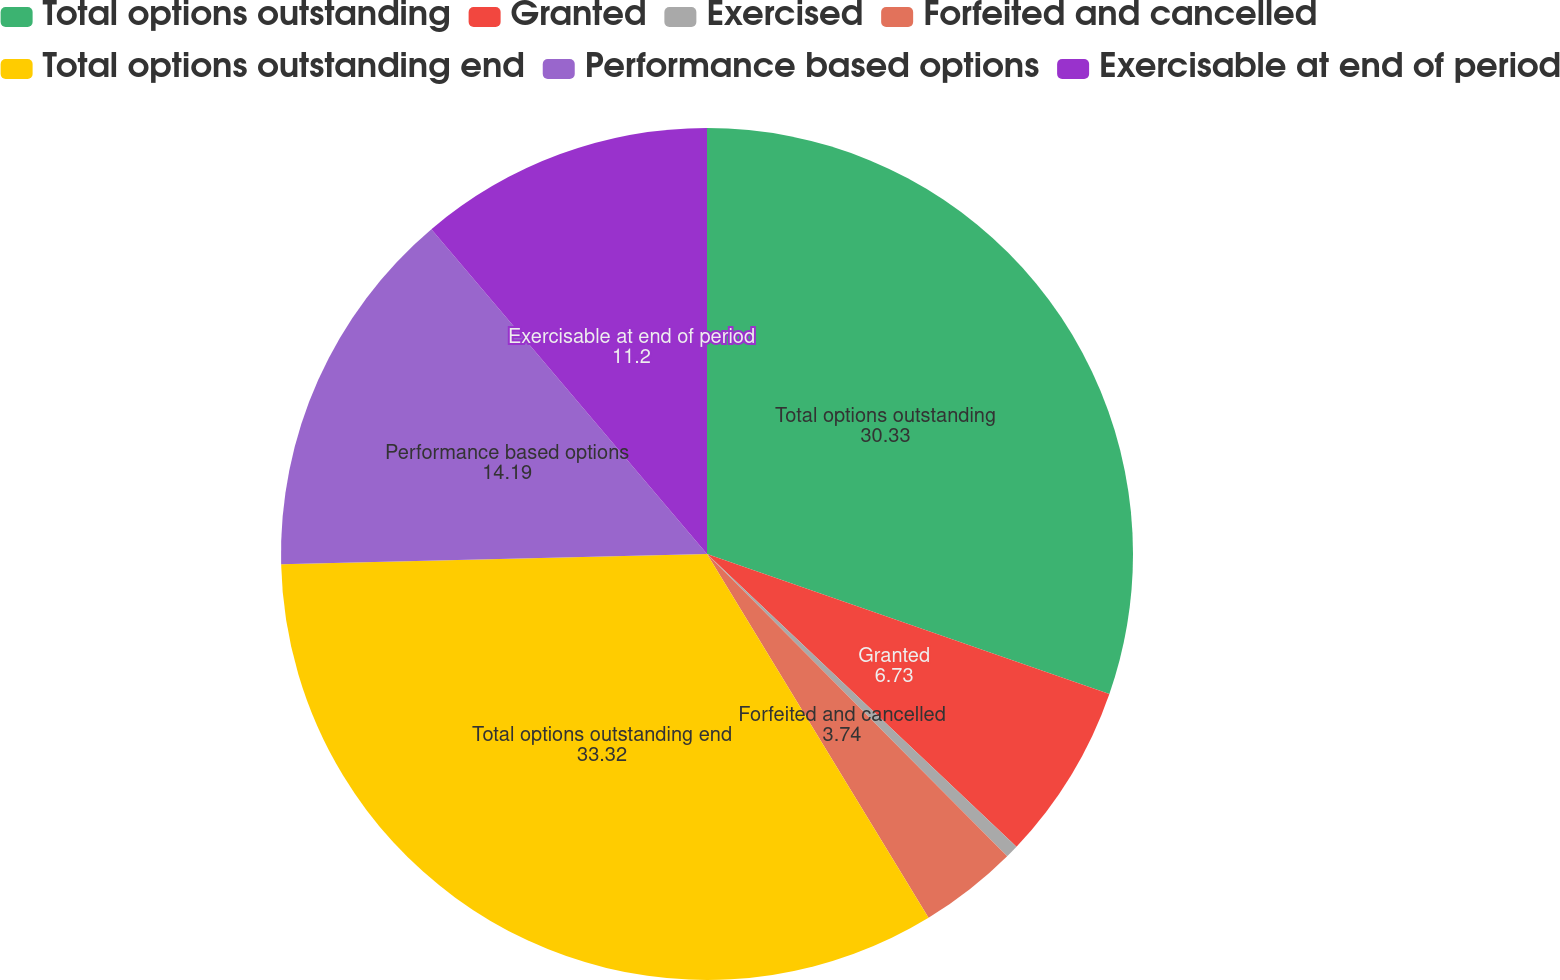<chart> <loc_0><loc_0><loc_500><loc_500><pie_chart><fcel>Total options outstanding<fcel>Granted<fcel>Exercised<fcel>Forfeited and cancelled<fcel>Total options outstanding end<fcel>Performance based options<fcel>Exercisable at end of period<nl><fcel>30.33%<fcel>6.73%<fcel>0.5%<fcel>3.74%<fcel>33.32%<fcel>14.19%<fcel>11.2%<nl></chart> 